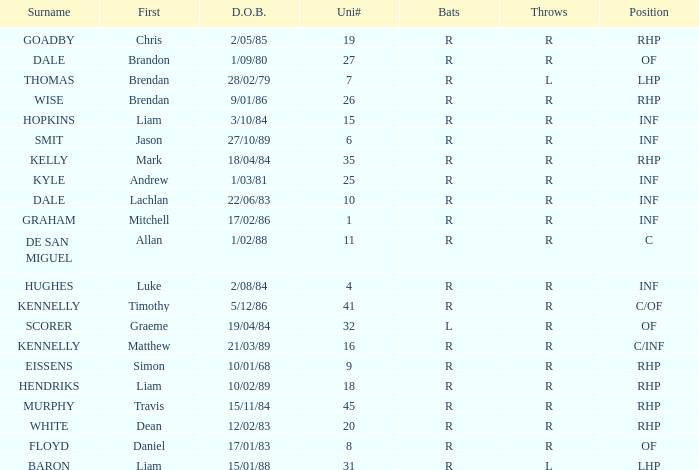Which batter has a uni# of 31? R. 